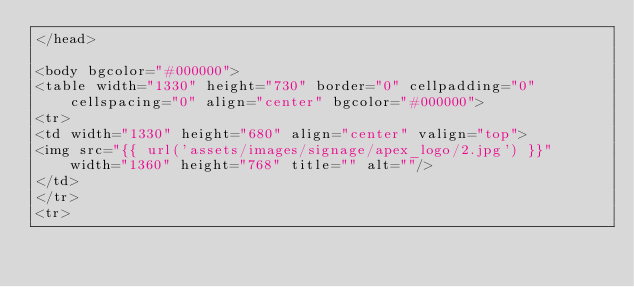<code> <loc_0><loc_0><loc_500><loc_500><_PHP_></head>

<body bgcolor="#000000">
<table width="1330" height="730" border="0" cellpadding="0" cellspacing="0" align="center" bgcolor="#000000">
<tr>
<td width="1330" height="680" align="center" valign="top">
<img src="{{ url('assets/images/signage/apex_logo/2.jpg') }}"  width="1360" height="768" title="" alt=""/>
</td>
</tr>
<tr></code> 